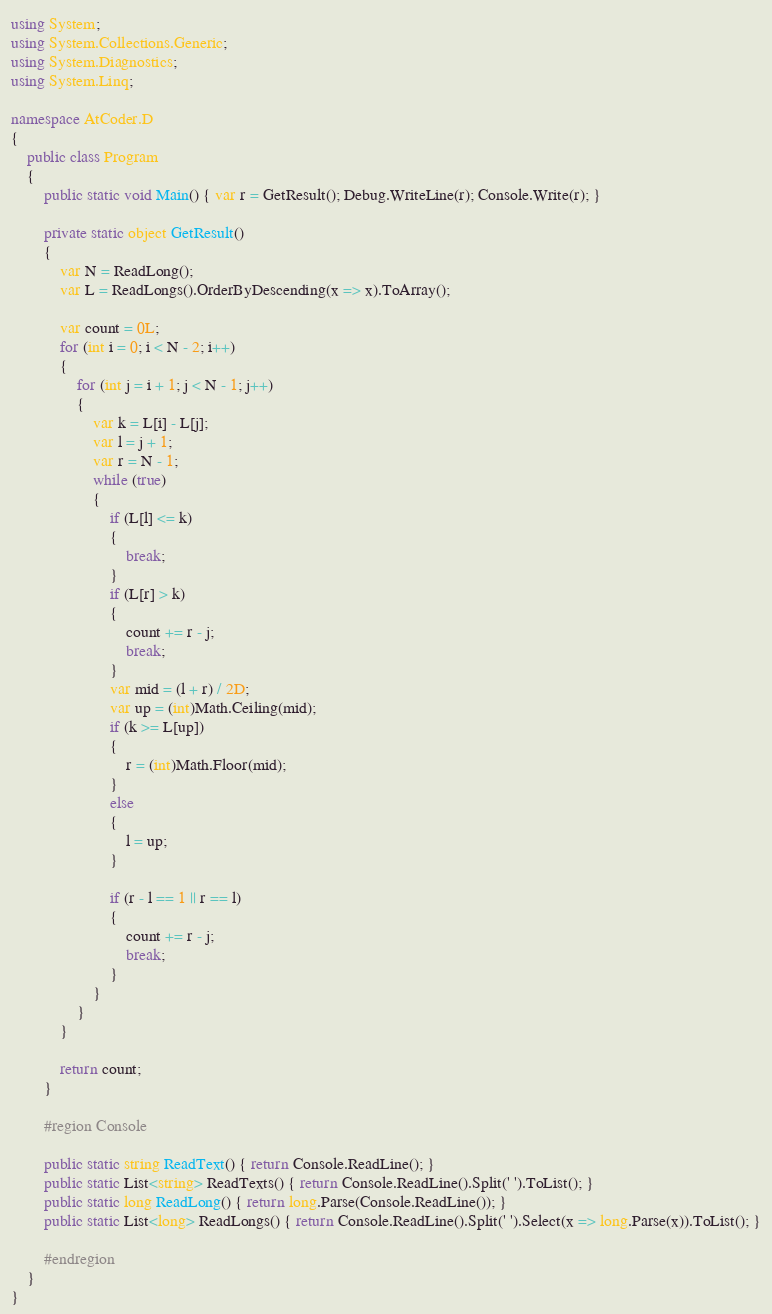<code> <loc_0><loc_0><loc_500><loc_500><_C#_>using System;
using System.Collections.Generic;
using System.Diagnostics;
using System.Linq;

namespace AtCoder.D
{
    public class Program
    {
        public static void Main() { var r = GetResult(); Debug.WriteLine(r); Console.Write(r); }

        private static object GetResult()
        {
            var N = ReadLong();
            var L = ReadLongs().OrderByDescending(x => x).ToArray();

            var count = 0L;
            for (int i = 0; i < N - 2; i++)
            {
                for (int j = i + 1; j < N - 1; j++)
                {
                    var k = L[i] - L[j];
                    var l = j + 1;
                    var r = N - 1;
                    while (true)
                    {
                        if (L[l] <= k)
                        {
                            break;
                        }
                        if (L[r] > k)
                        {
                            count += r - j;
                            break;
                        }
                        var mid = (l + r) / 2D;
                        var up = (int)Math.Ceiling(mid);
                        if (k >= L[up])
                        {
                            r = (int)Math.Floor(mid);
                        }
                        else
                        {
                            l = up;
                        }

                        if (r - l == 1 || r == l)
                        {
                            count += r - j;
                            break;
                        }
                    }
                }
            }

            return count;
        }

        #region Console

        public static string ReadText() { return Console.ReadLine(); }
        public static List<string> ReadTexts() { return Console.ReadLine().Split(' ').ToList(); }
        public static long ReadLong() { return long.Parse(Console.ReadLine()); }
        public static List<long> ReadLongs() { return Console.ReadLine().Split(' ').Select(x => long.Parse(x)).ToList(); }

        #endregion
    }
}
</code> 